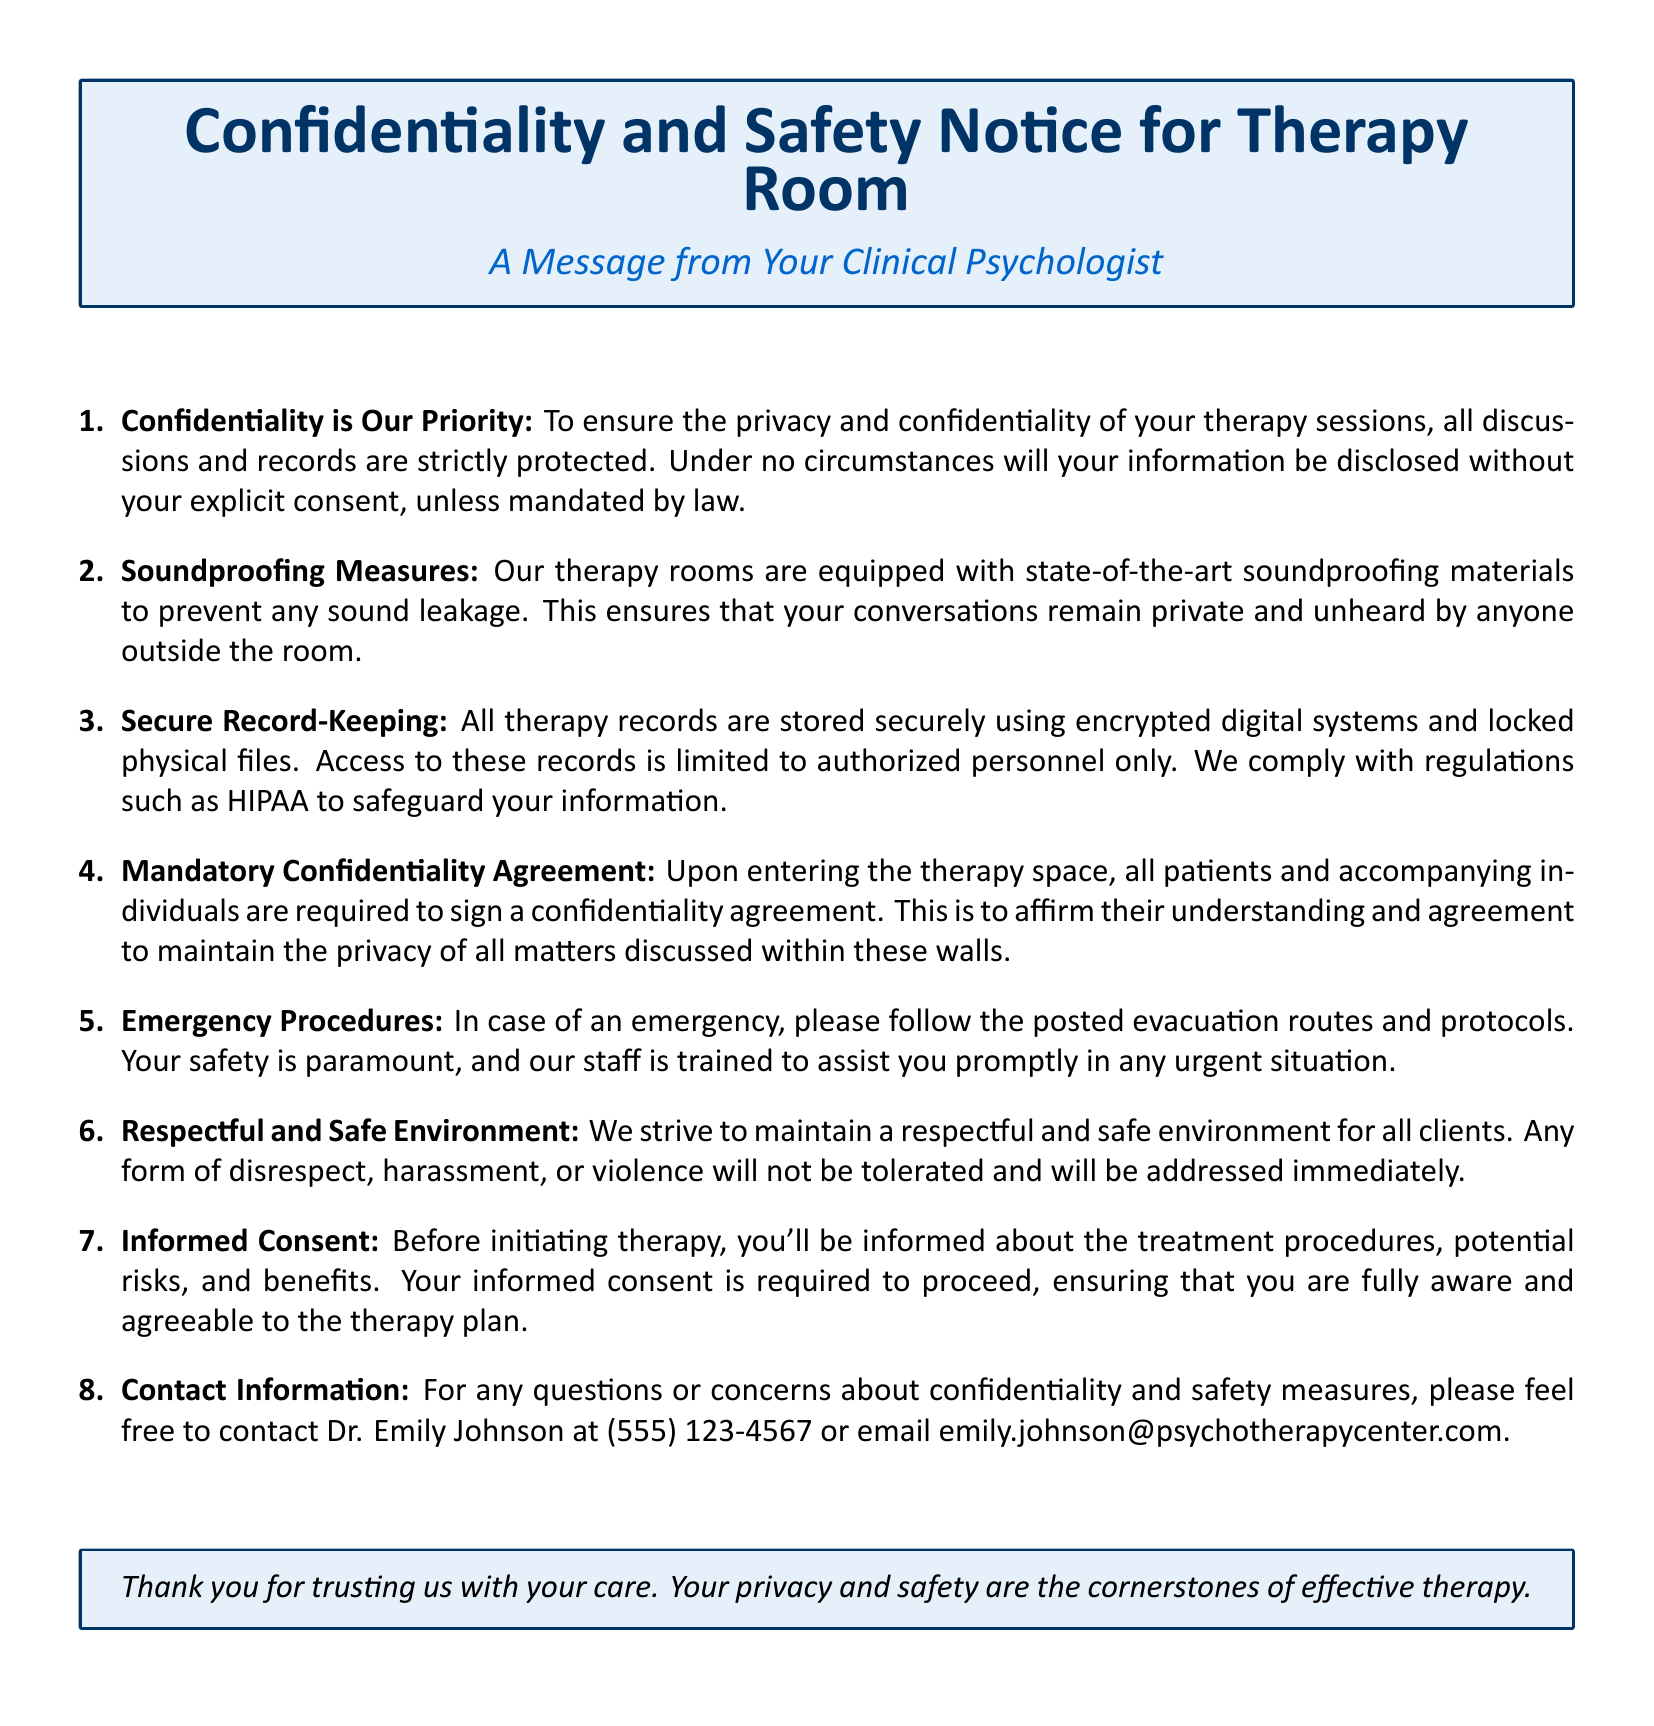What is the priority emphasized in the notice? The notice emphasizes that confidentiality is the priority for therapy sessions.
Answer: Confidentiality What material is used for preventing sound leakage? The notice states that state-of-the-art soundproofing materials are used in therapy rooms.
Answer: Soundproofing materials Who is the contact person for concerns about confidentiality? The notice provides contact information for Dr. Emily Johnson regarding confidentiality concerns.
Answer: Dr. Emily Johnson What must all patients sign upon entering the therapy space? The notice mentions that all patients must sign a confidentiality agreement upon entering the therapy space.
Answer: Confidentiality agreement What is the purpose of the informed consent mentioned in the document? The informed consent is aimed at ensuring patients are fully aware and agreeable to the therapy plan.
Answer: To ensure awareness and agreement What is the consequence of disrespect or harassment in the therapy room? The notice specifies that any form of disrespect or harassment will not be tolerated and will be addressed immediately.
Answer: Immediate action What regulations are mentioned to safeguard client information? The notice states that compliance with regulations such as HIPAA is followed to safeguard information.
Answer: HIPAA What type of procedures is emphasized in the emergency protocols? The notice emphasizes following posted evacuation routes and protocols in the case of an emergency.
Answer: Evacuation routes and protocols 